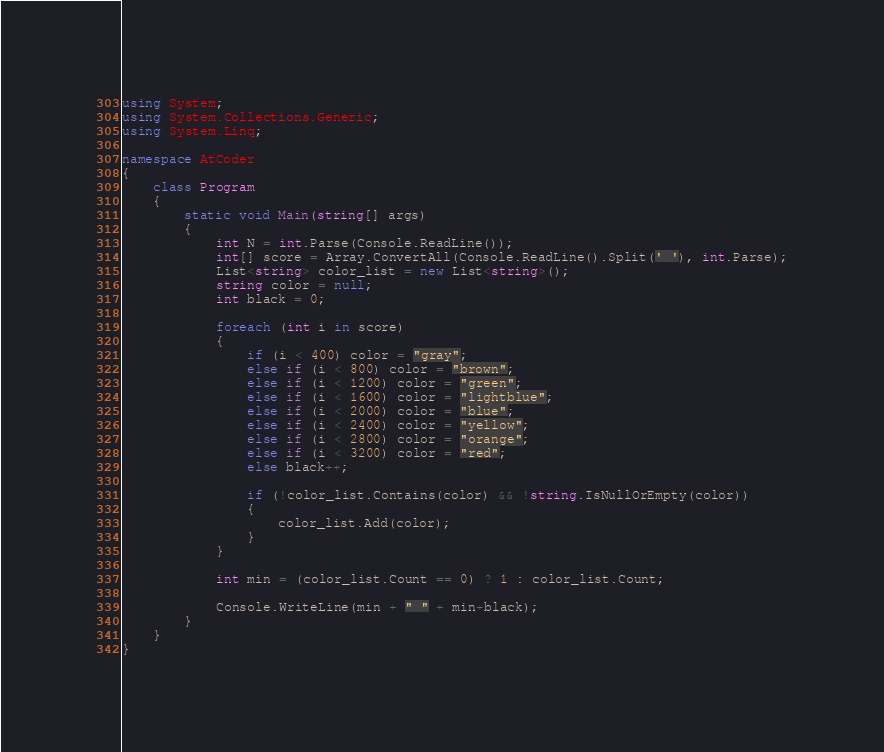Convert code to text. <code><loc_0><loc_0><loc_500><loc_500><_C#_>using System;
using System.Collections.Generic;
using System.Linq;

namespace AtCoder
{
    class Program
    {
        static void Main(string[] args)
        {
            int N = int.Parse(Console.ReadLine());
            int[] score = Array.ConvertAll(Console.ReadLine().Split(' '), int.Parse);
            List<string> color_list = new List<string>();
            string color = null;
            int black = 0;

            foreach (int i in score)
            {
                if (i < 400) color = "gray";
                else if (i < 800) color = "brown";
                else if (i < 1200) color = "green";
                else if (i < 1600) color = "lightblue";
                else if (i < 2000) color = "blue";
                else if (i < 2400) color = "yellow";
                else if (i < 2800) color = "orange";
                else if (i < 3200) color = "red";
                else black++;

                if (!color_list.Contains(color) && !string.IsNullOrEmpty(color))
                {
                    color_list.Add(color);
                }
            }

            int min = (color_list.Count == 0) ? 1 : color_list.Count;

            Console.WriteLine(min + " " + min+black);
        }
    }
}
</code> 